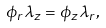<formula> <loc_0><loc_0><loc_500><loc_500>\phi _ { r } \lambda _ { z } = \phi _ { z } \lambda _ { r } ,</formula> 